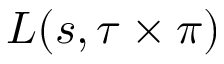<formula> <loc_0><loc_0><loc_500><loc_500>L ( s , \tau \times \pi )</formula> 